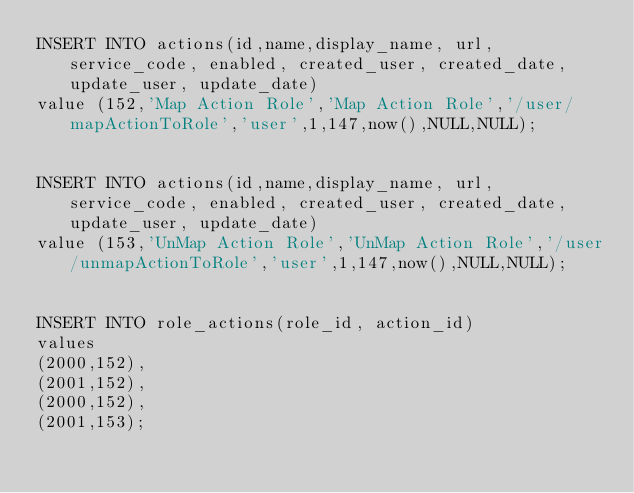<code> <loc_0><loc_0><loc_500><loc_500><_SQL_>INSERT INTO actions(id,name,display_name, url, service_code, enabled, created_user, created_date, update_user, update_date)
value (152,'Map Action Role','Map Action Role','/user/mapActionToRole','user',1,147,now(),NULL,NULL);


INSERT INTO actions(id,name,display_name, url, service_code, enabled, created_user, created_date, update_user, update_date)
value (153,'UnMap Action Role','UnMap Action Role','/user/unmapActionToRole','user',1,147,now(),NULL,NULL);


INSERT INTO role_actions(role_id, action_id)
values
(2000,152),
(2001,152),
(2000,152),
(2001,153);

</code> 